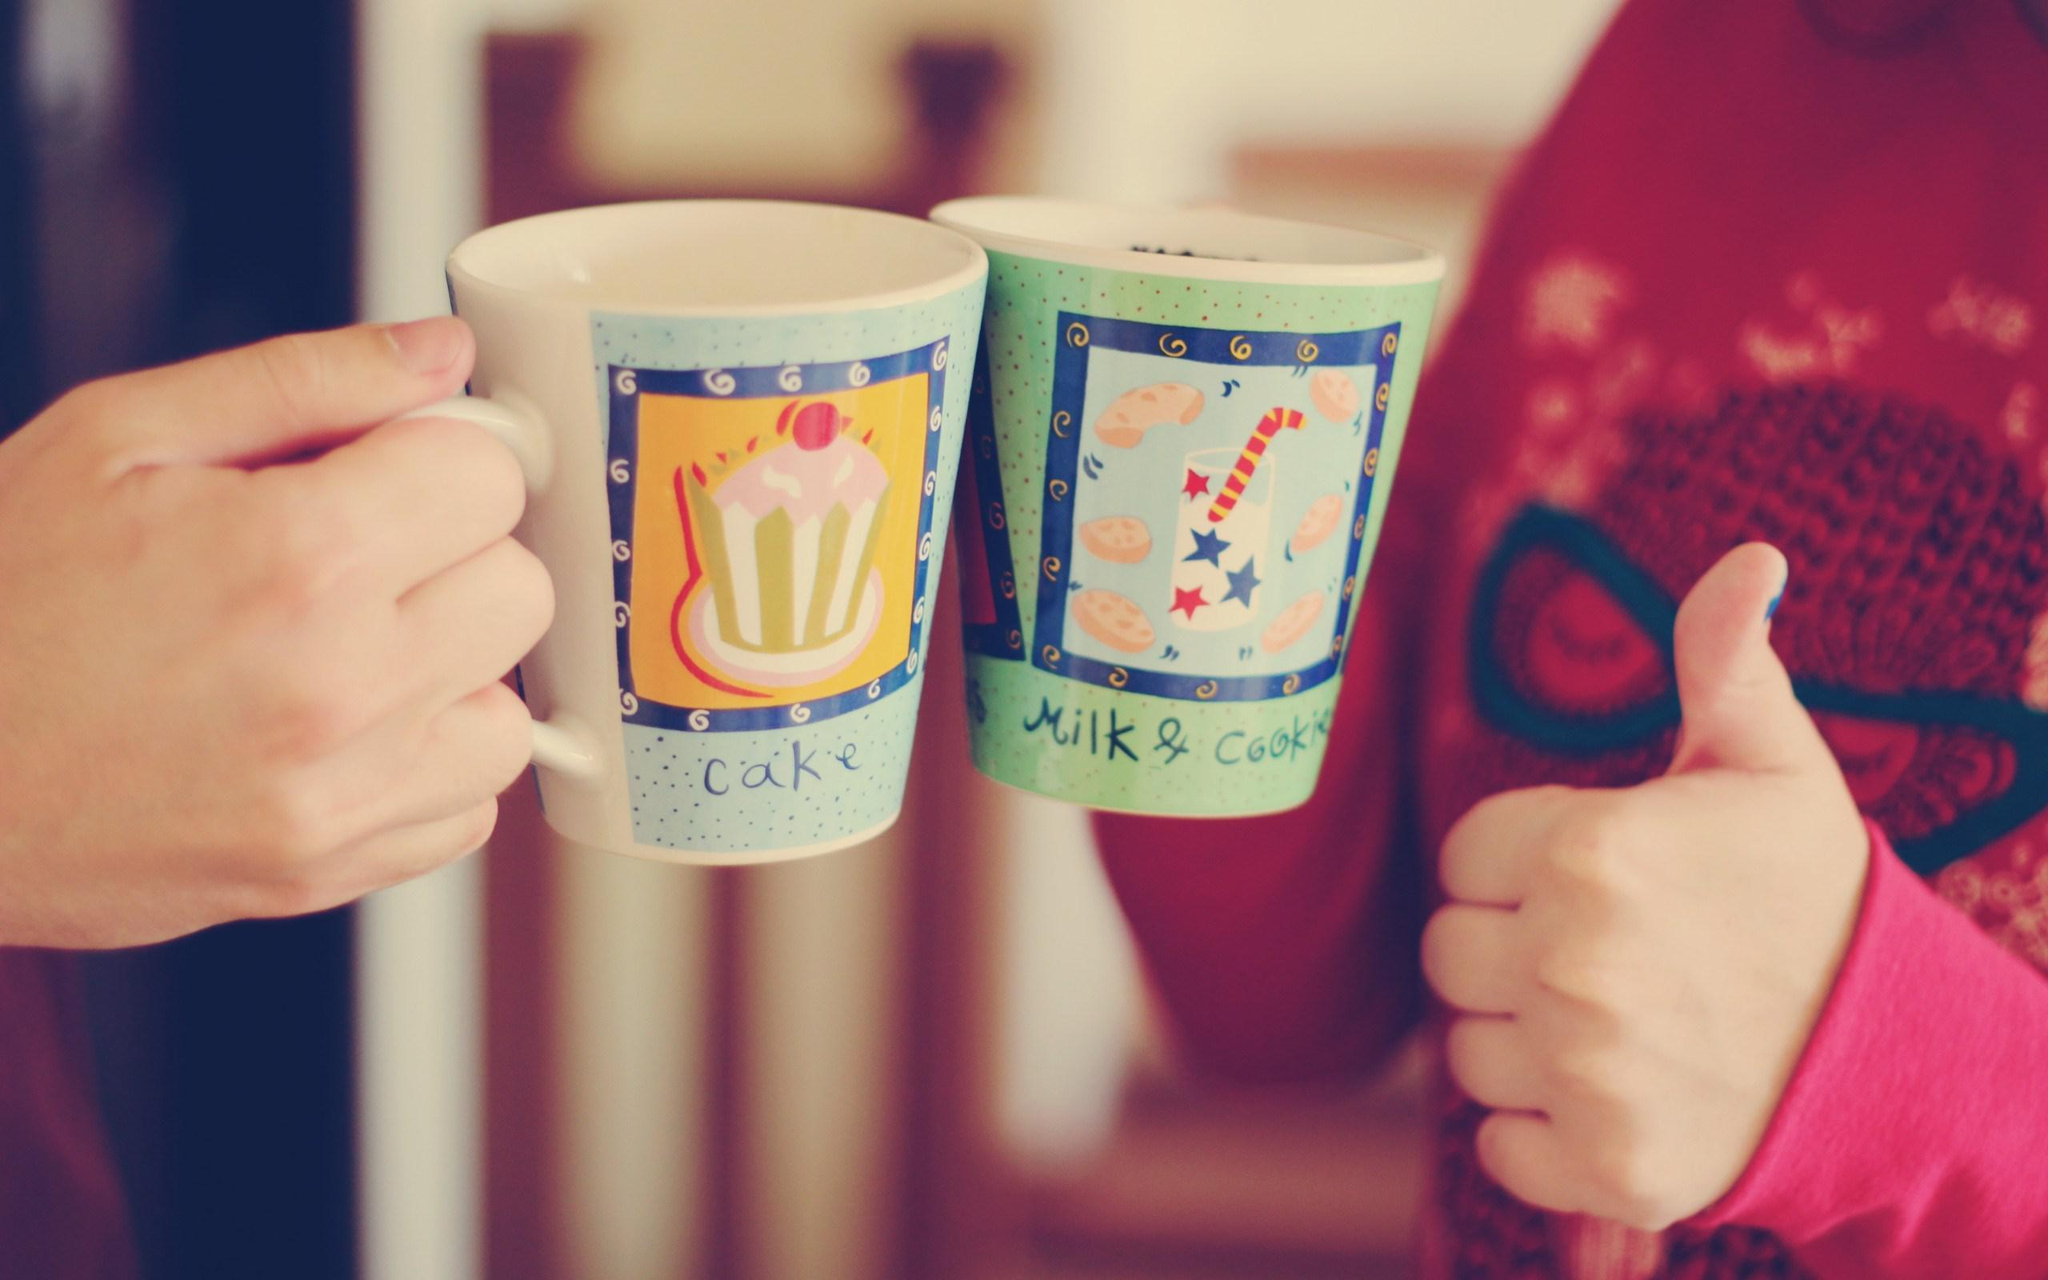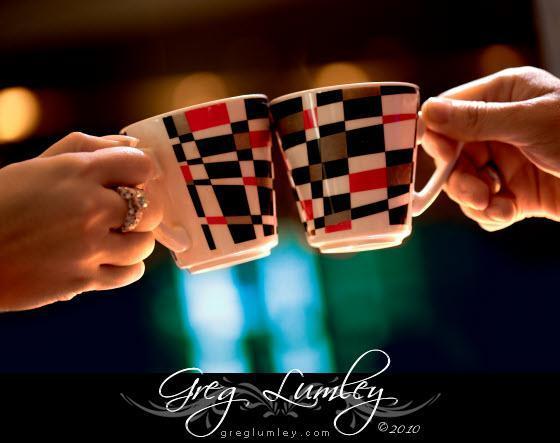The first image is the image on the left, the second image is the image on the right. Examine the images to the left and right. Is the description "There are exactly four cups." accurate? Answer yes or no. Yes. The first image is the image on the left, the second image is the image on the right. Assess this claim about the two images: "At least three people are drinking from mugs together in the image on the right.". Correct or not? Answer yes or no. No. 